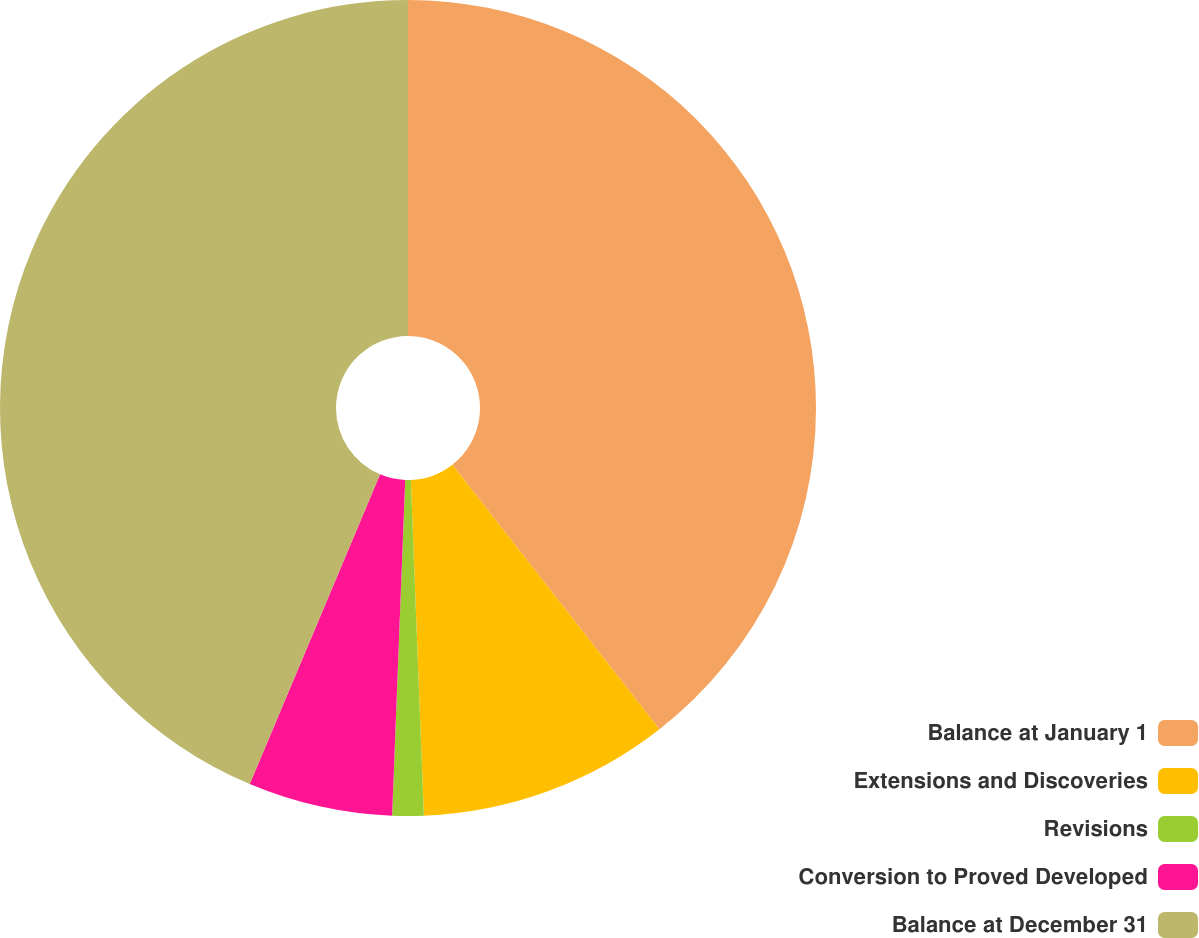Convert chart to OTSL. <chart><loc_0><loc_0><loc_500><loc_500><pie_chart><fcel>Balance at January 1<fcel>Extensions and Discoveries<fcel>Revisions<fcel>Conversion to Proved Developed<fcel>Balance at December 31<nl><fcel>39.43%<fcel>9.95%<fcel>1.24%<fcel>5.72%<fcel>43.66%<nl></chart> 